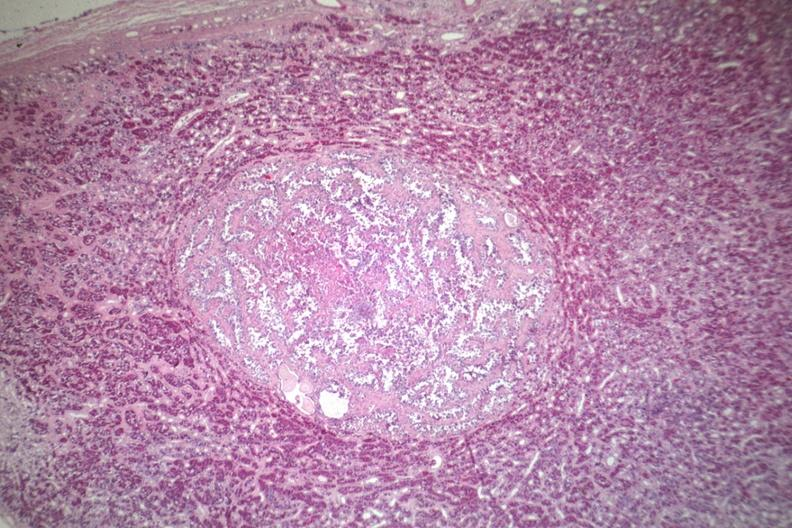s adenoma present?
Answer the question using a single word or phrase. Yes 